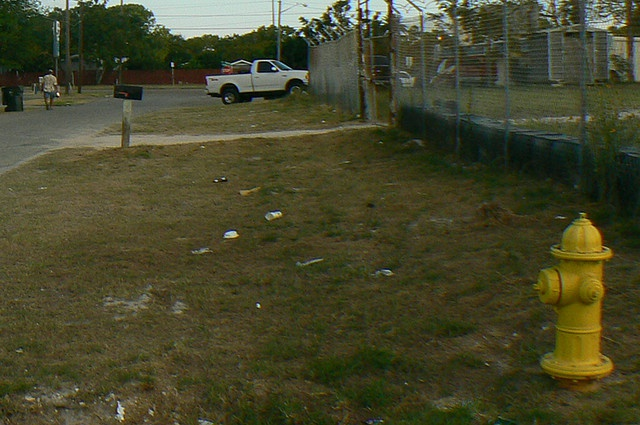Describe the objects in this image and their specific colors. I can see fire hydrant in black, olive, and maroon tones, truck in black, darkgray, and gray tones, car in black, gray, and darkgreen tones, people in black, gray, and darkgreen tones, and car in black, darkgreen, and gray tones in this image. 